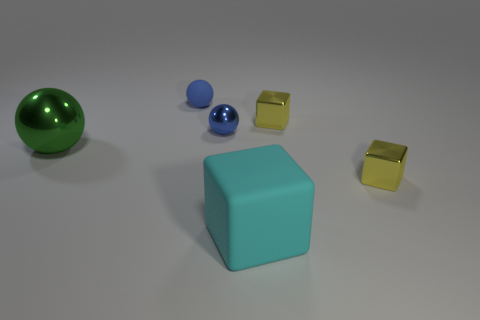There is a small blue matte thing; what shape is it?
Give a very brief answer. Sphere. There is a large green thing that is the same shape as the tiny blue matte thing; what material is it?
Make the answer very short. Metal. What number of yellow shiny things have the same size as the rubber sphere?
Your answer should be compact. 2. There is a blue metallic ball that is to the left of the big rubber cube; is there a object behind it?
Provide a succinct answer. Yes. How many blue things are either tiny metal cylinders or tiny shiny objects?
Give a very brief answer. 1. The big matte object has what color?
Keep it short and to the point. Cyan. What is the size of the blue thing that is made of the same material as the big block?
Ensure brevity in your answer.  Small. How many yellow objects have the same shape as the large cyan matte thing?
Provide a succinct answer. 2. Are there any other things that are the same size as the green sphere?
Keep it short and to the point. Yes. What size is the rubber ball that is behind the rubber object that is in front of the green sphere?
Offer a very short reply. Small. 